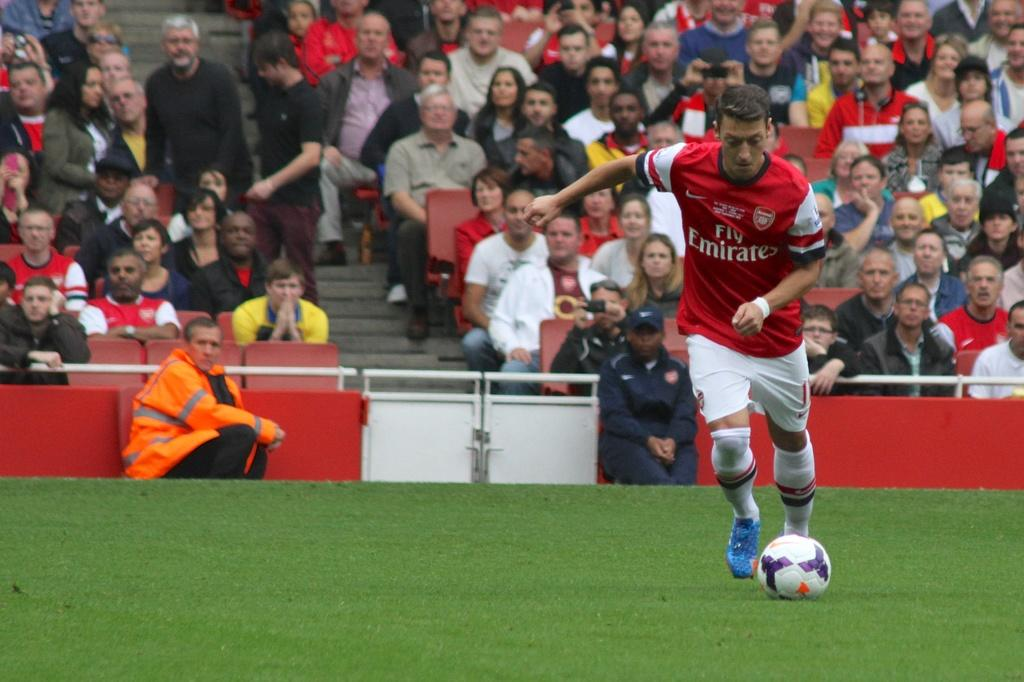<image>
Render a clear and concise summary of the photo. a man in a Fly Emirates jersey about to kick a ball on the field 